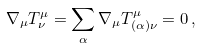<formula> <loc_0><loc_0><loc_500><loc_500>\nabla _ { \mu } T ^ { \mu } _ { \nu } = \sum _ { \alpha } \nabla _ { \mu } T ^ { \mu } _ { ( \alpha ) \nu } = 0 \, ,</formula> 